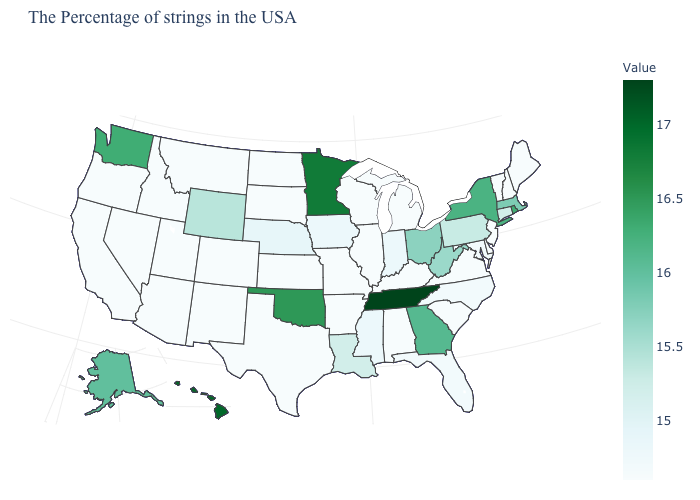Which states have the lowest value in the USA?
Quick response, please. Maine, New Hampshire, Vermont, New Jersey, Delaware, Virginia, South Carolina, Michigan, Kentucky, Alabama, Wisconsin, Illinois, Missouri, Arkansas, Kansas, Texas, South Dakota, North Dakota, Colorado, New Mexico, Utah, Montana, Arizona, Idaho, Nevada, California, Oregon. Among the states that border Virginia , which have the lowest value?
Write a very short answer. Kentucky. Is the legend a continuous bar?
Concise answer only. Yes. Which states have the lowest value in the Northeast?
Short answer required. Maine, New Hampshire, Vermont, New Jersey. Does Colorado have the lowest value in the West?
Answer briefly. Yes. Which states hav the highest value in the MidWest?
Be succinct. Minnesota. Among the states that border New York , which have the highest value?
Keep it brief. Massachusetts. Which states hav the highest value in the West?
Quick response, please. Hawaii. Among the states that border Indiana , does Illinois have the highest value?
Short answer required. No. 